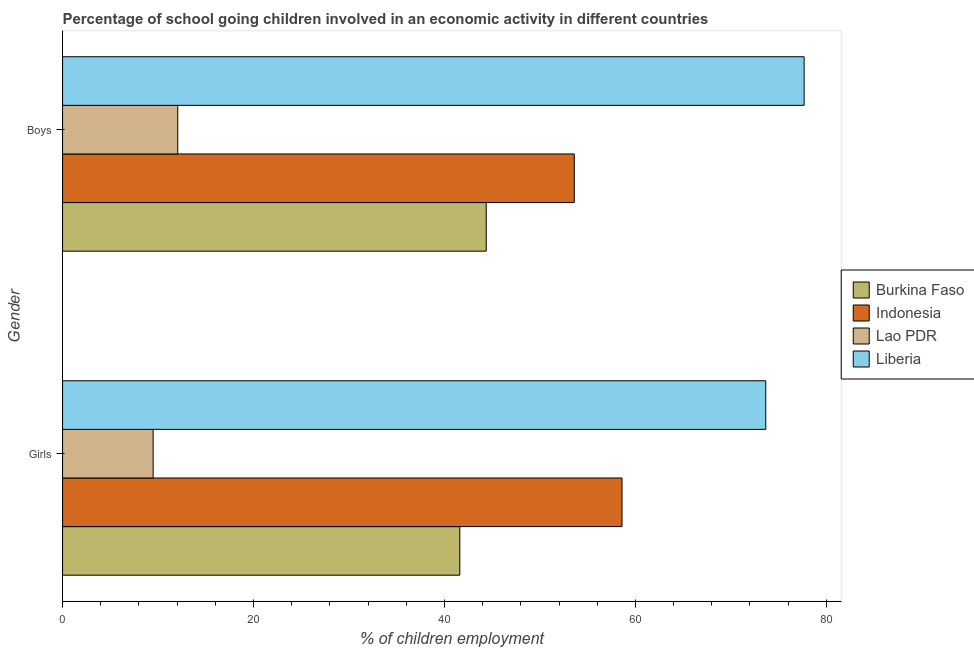How many different coloured bars are there?
Provide a succinct answer. 4. How many bars are there on the 1st tick from the top?
Your answer should be compact. 4. What is the label of the 1st group of bars from the top?
Provide a short and direct response. Boys. What is the percentage of school going boys in Indonesia?
Make the answer very short. 53.6. Across all countries, what is the maximum percentage of school going boys?
Ensure brevity in your answer.  77.68. Across all countries, what is the minimum percentage of school going girls?
Offer a terse response. 9.49. In which country was the percentage of school going boys maximum?
Keep it short and to the point. Liberia. In which country was the percentage of school going boys minimum?
Offer a terse response. Lao PDR. What is the total percentage of school going girls in the graph?
Offer a terse response. 183.36. What is the difference between the percentage of school going boys in Lao PDR and that in Indonesia?
Make the answer very short. -41.53. What is the difference between the percentage of school going girls in Indonesia and the percentage of school going boys in Burkina Faso?
Provide a succinct answer. 14.22. What is the average percentage of school going boys per country?
Provide a short and direct response. 46.93. In how many countries, is the percentage of school going boys greater than 72 %?
Offer a terse response. 1. What is the ratio of the percentage of school going boys in Lao PDR to that in Liberia?
Provide a short and direct response. 0.16. In how many countries, is the percentage of school going girls greater than the average percentage of school going girls taken over all countries?
Offer a terse response. 2. What does the 3rd bar from the top in Boys represents?
Provide a short and direct response. Indonesia. What does the 4th bar from the bottom in Girls represents?
Provide a succinct answer. Liberia. How many bars are there?
Provide a succinct answer. 8. Are all the bars in the graph horizontal?
Your answer should be very brief. Yes. How many countries are there in the graph?
Offer a very short reply. 4. What is the difference between two consecutive major ticks on the X-axis?
Ensure brevity in your answer.  20. Are the values on the major ticks of X-axis written in scientific E-notation?
Your answer should be very brief. No. What is the title of the graph?
Keep it short and to the point. Percentage of school going children involved in an economic activity in different countries. What is the label or title of the X-axis?
Offer a terse response. % of children employment. What is the label or title of the Y-axis?
Keep it short and to the point. Gender. What is the % of children employment in Burkina Faso in Girls?
Ensure brevity in your answer.  41.61. What is the % of children employment in Indonesia in Girls?
Provide a succinct answer. 58.6. What is the % of children employment of Lao PDR in Girls?
Give a very brief answer. 9.49. What is the % of children employment in Liberia in Girls?
Provide a succinct answer. 73.66. What is the % of children employment in Burkina Faso in Boys?
Keep it short and to the point. 44.38. What is the % of children employment in Indonesia in Boys?
Provide a short and direct response. 53.6. What is the % of children employment of Lao PDR in Boys?
Ensure brevity in your answer.  12.07. What is the % of children employment of Liberia in Boys?
Your answer should be very brief. 77.68. Across all Gender, what is the maximum % of children employment of Burkina Faso?
Your answer should be compact. 44.38. Across all Gender, what is the maximum % of children employment of Indonesia?
Your response must be concise. 58.6. Across all Gender, what is the maximum % of children employment in Lao PDR?
Provide a short and direct response. 12.07. Across all Gender, what is the maximum % of children employment in Liberia?
Offer a very short reply. 77.68. Across all Gender, what is the minimum % of children employment of Burkina Faso?
Offer a terse response. 41.61. Across all Gender, what is the minimum % of children employment of Indonesia?
Offer a terse response. 53.6. Across all Gender, what is the minimum % of children employment in Lao PDR?
Keep it short and to the point. 9.49. Across all Gender, what is the minimum % of children employment in Liberia?
Provide a short and direct response. 73.66. What is the total % of children employment in Burkina Faso in the graph?
Ensure brevity in your answer.  85.99. What is the total % of children employment in Indonesia in the graph?
Keep it short and to the point. 112.2. What is the total % of children employment in Lao PDR in the graph?
Your answer should be very brief. 21.55. What is the total % of children employment of Liberia in the graph?
Ensure brevity in your answer.  151.34. What is the difference between the % of children employment of Burkina Faso in Girls and that in Boys?
Keep it short and to the point. -2.77. What is the difference between the % of children employment in Indonesia in Girls and that in Boys?
Ensure brevity in your answer.  5. What is the difference between the % of children employment in Lao PDR in Girls and that in Boys?
Your response must be concise. -2.58. What is the difference between the % of children employment of Liberia in Girls and that in Boys?
Give a very brief answer. -4.02. What is the difference between the % of children employment in Burkina Faso in Girls and the % of children employment in Indonesia in Boys?
Your response must be concise. -11.99. What is the difference between the % of children employment of Burkina Faso in Girls and the % of children employment of Lao PDR in Boys?
Your answer should be very brief. 29.54. What is the difference between the % of children employment of Burkina Faso in Girls and the % of children employment of Liberia in Boys?
Ensure brevity in your answer.  -36.07. What is the difference between the % of children employment of Indonesia in Girls and the % of children employment of Lao PDR in Boys?
Offer a very short reply. 46.53. What is the difference between the % of children employment of Indonesia in Girls and the % of children employment of Liberia in Boys?
Offer a very short reply. -19.08. What is the difference between the % of children employment of Lao PDR in Girls and the % of children employment of Liberia in Boys?
Offer a terse response. -68.19. What is the average % of children employment of Burkina Faso per Gender?
Give a very brief answer. 42.99. What is the average % of children employment of Indonesia per Gender?
Provide a succinct answer. 56.1. What is the average % of children employment of Lao PDR per Gender?
Offer a terse response. 10.78. What is the average % of children employment of Liberia per Gender?
Ensure brevity in your answer.  75.67. What is the difference between the % of children employment in Burkina Faso and % of children employment in Indonesia in Girls?
Your response must be concise. -16.99. What is the difference between the % of children employment of Burkina Faso and % of children employment of Lao PDR in Girls?
Keep it short and to the point. 32.12. What is the difference between the % of children employment in Burkina Faso and % of children employment in Liberia in Girls?
Your answer should be very brief. -32.05. What is the difference between the % of children employment of Indonesia and % of children employment of Lao PDR in Girls?
Your answer should be compact. 49.11. What is the difference between the % of children employment of Indonesia and % of children employment of Liberia in Girls?
Your response must be concise. -15.06. What is the difference between the % of children employment in Lao PDR and % of children employment in Liberia in Girls?
Your answer should be compact. -64.17. What is the difference between the % of children employment of Burkina Faso and % of children employment of Indonesia in Boys?
Provide a short and direct response. -9.22. What is the difference between the % of children employment in Burkina Faso and % of children employment in Lao PDR in Boys?
Provide a succinct answer. 32.31. What is the difference between the % of children employment of Burkina Faso and % of children employment of Liberia in Boys?
Offer a terse response. -33.3. What is the difference between the % of children employment of Indonesia and % of children employment of Lao PDR in Boys?
Keep it short and to the point. 41.53. What is the difference between the % of children employment in Indonesia and % of children employment in Liberia in Boys?
Offer a terse response. -24.08. What is the difference between the % of children employment of Lao PDR and % of children employment of Liberia in Boys?
Offer a very short reply. -65.61. What is the ratio of the % of children employment in Burkina Faso in Girls to that in Boys?
Offer a terse response. 0.94. What is the ratio of the % of children employment in Indonesia in Girls to that in Boys?
Ensure brevity in your answer.  1.09. What is the ratio of the % of children employment in Lao PDR in Girls to that in Boys?
Give a very brief answer. 0.79. What is the ratio of the % of children employment of Liberia in Girls to that in Boys?
Provide a succinct answer. 0.95. What is the difference between the highest and the second highest % of children employment of Burkina Faso?
Provide a short and direct response. 2.77. What is the difference between the highest and the second highest % of children employment of Lao PDR?
Keep it short and to the point. 2.58. What is the difference between the highest and the second highest % of children employment of Liberia?
Provide a succinct answer. 4.02. What is the difference between the highest and the lowest % of children employment in Burkina Faso?
Make the answer very short. 2.77. What is the difference between the highest and the lowest % of children employment of Indonesia?
Offer a very short reply. 5. What is the difference between the highest and the lowest % of children employment in Lao PDR?
Provide a short and direct response. 2.58. What is the difference between the highest and the lowest % of children employment of Liberia?
Offer a very short reply. 4.02. 